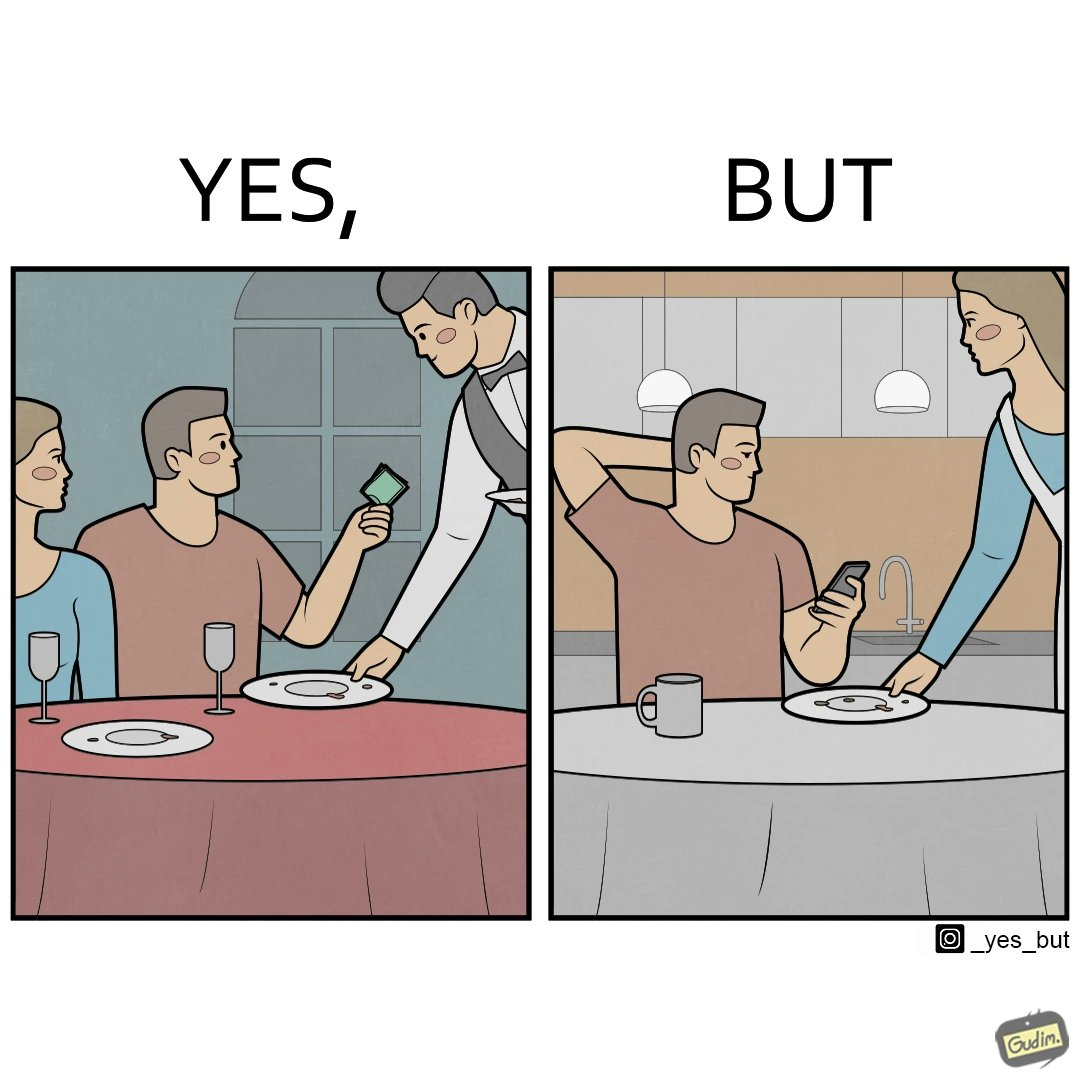Describe the content of this image. The image is ironical, as a man tips the waiter at a restaurant for the meal, but seems to not even acknowledge when his wife has made the meal for him at home. 